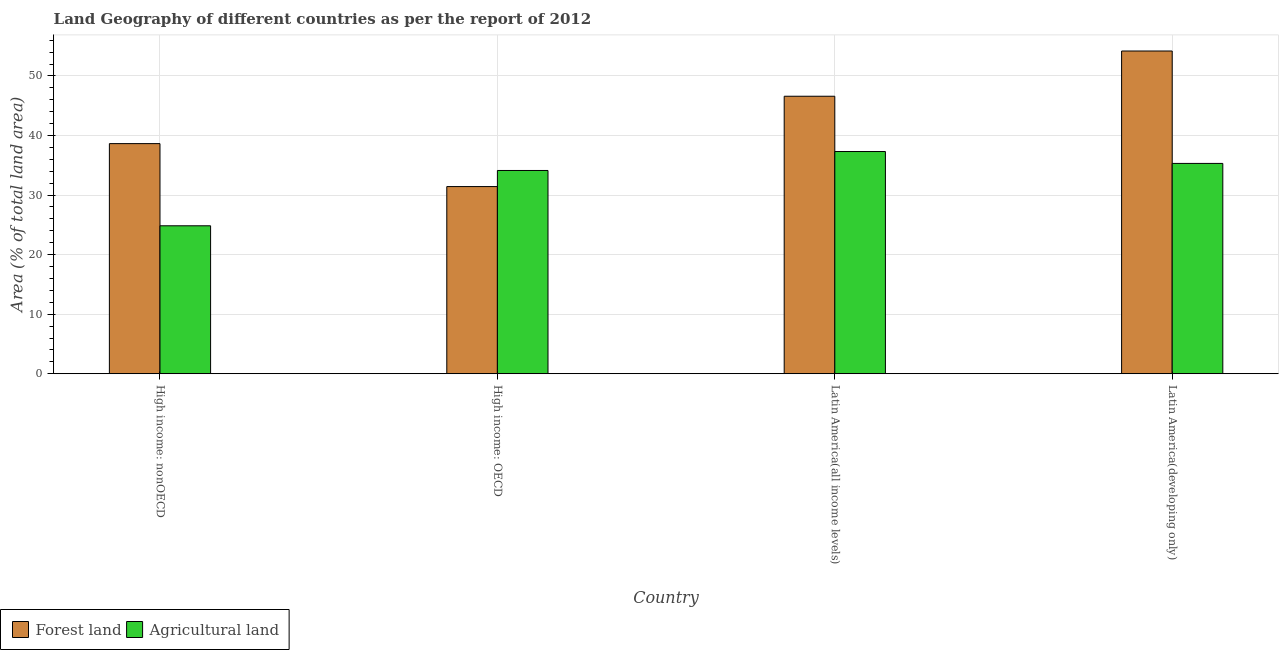Are the number of bars per tick equal to the number of legend labels?
Your answer should be compact. Yes. What is the label of the 3rd group of bars from the left?
Make the answer very short. Latin America(all income levels). In how many cases, is the number of bars for a given country not equal to the number of legend labels?
Provide a succinct answer. 0. What is the percentage of land area under agriculture in Latin America(developing only)?
Offer a terse response. 35.32. Across all countries, what is the maximum percentage of land area under agriculture?
Offer a terse response. 37.31. Across all countries, what is the minimum percentage of land area under forests?
Offer a terse response. 31.43. In which country was the percentage of land area under forests maximum?
Offer a terse response. Latin America(developing only). In which country was the percentage of land area under forests minimum?
Keep it short and to the point. High income: OECD. What is the total percentage of land area under forests in the graph?
Offer a terse response. 170.84. What is the difference between the percentage of land area under agriculture in High income: OECD and that in High income: nonOECD?
Keep it short and to the point. 9.29. What is the difference between the percentage of land area under forests in Latin America(developing only) and the percentage of land area under agriculture in High income: nonOECD?
Keep it short and to the point. 29.35. What is the average percentage of land area under forests per country?
Offer a terse response. 42.71. What is the difference between the percentage of land area under agriculture and percentage of land area under forests in Latin America(developing only)?
Provide a short and direct response. -18.87. What is the ratio of the percentage of land area under forests in High income: nonOECD to that in Latin America(all income levels)?
Offer a terse response. 0.83. Is the percentage of land area under forests in High income: nonOECD less than that in Latin America(developing only)?
Your answer should be compact. Yes. What is the difference between the highest and the second highest percentage of land area under forests?
Provide a succinct answer. 7.59. What is the difference between the highest and the lowest percentage of land area under forests?
Your response must be concise. 22.76. In how many countries, is the percentage of land area under agriculture greater than the average percentage of land area under agriculture taken over all countries?
Ensure brevity in your answer.  3. Is the sum of the percentage of land area under forests in High income: OECD and High income: nonOECD greater than the maximum percentage of land area under agriculture across all countries?
Provide a succinct answer. Yes. What does the 1st bar from the left in High income: nonOECD represents?
Ensure brevity in your answer.  Forest land. What does the 2nd bar from the right in High income: nonOECD represents?
Make the answer very short. Forest land. How many countries are there in the graph?
Provide a short and direct response. 4. What is the difference between two consecutive major ticks on the Y-axis?
Give a very brief answer. 10. Does the graph contain any zero values?
Give a very brief answer. No. Where does the legend appear in the graph?
Make the answer very short. Bottom left. How are the legend labels stacked?
Give a very brief answer. Horizontal. What is the title of the graph?
Provide a short and direct response. Land Geography of different countries as per the report of 2012. What is the label or title of the X-axis?
Keep it short and to the point. Country. What is the label or title of the Y-axis?
Make the answer very short. Area (% of total land area). What is the Area (% of total land area) in Forest land in High income: nonOECD?
Your answer should be very brief. 38.64. What is the Area (% of total land area) in Agricultural land in High income: nonOECD?
Make the answer very short. 24.84. What is the Area (% of total land area) in Forest land in High income: OECD?
Keep it short and to the point. 31.43. What is the Area (% of total land area) in Agricultural land in High income: OECD?
Provide a succinct answer. 34.13. What is the Area (% of total land area) of Forest land in Latin America(all income levels)?
Ensure brevity in your answer.  46.59. What is the Area (% of total land area) of Agricultural land in Latin America(all income levels)?
Provide a short and direct response. 37.31. What is the Area (% of total land area) of Forest land in Latin America(developing only)?
Ensure brevity in your answer.  54.19. What is the Area (% of total land area) of Agricultural land in Latin America(developing only)?
Make the answer very short. 35.32. Across all countries, what is the maximum Area (% of total land area) of Forest land?
Ensure brevity in your answer.  54.19. Across all countries, what is the maximum Area (% of total land area) of Agricultural land?
Provide a short and direct response. 37.31. Across all countries, what is the minimum Area (% of total land area) in Forest land?
Your answer should be compact. 31.43. Across all countries, what is the minimum Area (% of total land area) of Agricultural land?
Provide a short and direct response. 24.84. What is the total Area (% of total land area) in Forest land in the graph?
Ensure brevity in your answer.  170.84. What is the total Area (% of total land area) in Agricultural land in the graph?
Provide a short and direct response. 131.6. What is the difference between the Area (% of total land area) of Forest land in High income: nonOECD and that in High income: OECD?
Your response must be concise. 7.21. What is the difference between the Area (% of total land area) of Agricultural land in High income: nonOECD and that in High income: OECD?
Offer a very short reply. -9.29. What is the difference between the Area (% of total land area) in Forest land in High income: nonOECD and that in Latin America(all income levels)?
Offer a very short reply. -7.95. What is the difference between the Area (% of total land area) in Agricultural land in High income: nonOECD and that in Latin America(all income levels)?
Ensure brevity in your answer.  -12.47. What is the difference between the Area (% of total land area) of Forest land in High income: nonOECD and that in Latin America(developing only)?
Make the answer very short. -15.55. What is the difference between the Area (% of total land area) of Agricultural land in High income: nonOECD and that in Latin America(developing only)?
Give a very brief answer. -10.47. What is the difference between the Area (% of total land area) of Forest land in High income: OECD and that in Latin America(all income levels)?
Your answer should be compact. -15.17. What is the difference between the Area (% of total land area) of Agricultural land in High income: OECD and that in Latin America(all income levels)?
Ensure brevity in your answer.  -3.18. What is the difference between the Area (% of total land area) in Forest land in High income: OECD and that in Latin America(developing only)?
Offer a terse response. -22.76. What is the difference between the Area (% of total land area) of Agricultural land in High income: OECD and that in Latin America(developing only)?
Your response must be concise. -1.19. What is the difference between the Area (% of total land area) in Forest land in Latin America(all income levels) and that in Latin America(developing only)?
Your answer should be compact. -7.59. What is the difference between the Area (% of total land area) of Agricultural land in Latin America(all income levels) and that in Latin America(developing only)?
Your answer should be compact. 2. What is the difference between the Area (% of total land area) of Forest land in High income: nonOECD and the Area (% of total land area) of Agricultural land in High income: OECD?
Offer a terse response. 4.51. What is the difference between the Area (% of total land area) in Forest land in High income: nonOECD and the Area (% of total land area) in Agricultural land in Latin America(all income levels)?
Offer a very short reply. 1.33. What is the difference between the Area (% of total land area) in Forest land in High income: nonOECD and the Area (% of total land area) in Agricultural land in Latin America(developing only)?
Give a very brief answer. 3.32. What is the difference between the Area (% of total land area) of Forest land in High income: OECD and the Area (% of total land area) of Agricultural land in Latin America(all income levels)?
Provide a short and direct response. -5.89. What is the difference between the Area (% of total land area) of Forest land in High income: OECD and the Area (% of total land area) of Agricultural land in Latin America(developing only)?
Your answer should be very brief. -3.89. What is the difference between the Area (% of total land area) in Forest land in Latin America(all income levels) and the Area (% of total land area) in Agricultural land in Latin America(developing only)?
Provide a short and direct response. 11.28. What is the average Area (% of total land area) of Forest land per country?
Keep it short and to the point. 42.71. What is the average Area (% of total land area) of Agricultural land per country?
Make the answer very short. 32.9. What is the difference between the Area (% of total land area) in Forest land and Area (% of total land area) in Agricultural land in High income: nonOECD?
Your response must be concise. 13.8. What is the difference between the Area (% of total land area) of Forest land and Area (% of total land area) of Agricultural land in High income: OECD?
Keep it short and to the point. -2.7. What is the difference between the Area (% of total land area) of Forest land and Area (% of total land area) of Agricultural land in Latin America(all income levels)?
Give a very brief answer. 9.28. What is the difference between the Area (% of total land area) in Forest land and Area (% of total land area) in Agricultural land in Latin America(developing only)?
Offer a very short reply. 18.87. What is the ratio of the Area (% of total land area) of Forest land in High income: nonOECD to that in High income: OECD?
Give a very brief answer. 1.23. What is the ratio of the Area (% of total land area) in Agricultural land in High income: nonOECD to that in High income: OECD?
Give a very brief answer. 0.73. What is the ratio of the Area (% of total land area) in Forest land in High income: nonOECD to that in Latin America(all income levels)?
Offer a very short reply. 0.83. What is the ratio of the Area (% of total land area) of Agricultural land in High income: nonOECD to that in Latin America(all income levels)?
Give a very brief answer. 0.67. What is the ratio of the Area (% of total land area) in Forest land in High income: nonOECD to that in Latin America(developing only)?
Offer a terse response. 0.71. What is the ratio of the Area (% of total land area) in Agricultural land in High income: nonOECD to that in Latin America(developing only)?
Make the answer very short. 0.7. What is the ratio of the Area (% of total land area) of Forest land in High income: OECD to that in Latin America(all income levels)?
Your answer should be compact. 0.67. What is the ratio of the Area (% of total land area) in Agricultural land in High income: OECD to that in Latin America(all income levels)?
Provide a short and direct response. 0.91. What is the ratio of the Area (% of total land area) in Forest land in High income: OECD to that in Latin America(developing only)?
Provide a short and direct response. 0.58. What is the ratio of the Area (% of total land area) in Agricultural land in High income: OECD to that in Latin America(developing only)?
Ensure brevity in your answer.  0.97. What is the ratio of the Area (% of total land area) of Forest land in Latin America(all income levels) to that in Latin America(developing only)?
Offer a very short reply. 0.86. What is the ratio of the Area (% of total land area) in Agricultural land in Latin America(all income levels) to that in Latin America(developing only)?
Your answer should be very brief. 1.06. What is the difference between the highest and the second highest Area (% of total land area) of Forest land?
Give a very brief answer. 7.59. What is the difference between the highest and the second highest Area (% of total land area) in Agricultural land?
Ensure brevity in your answer.  2. What is the difference between the highest and the lowest Area (% of total land area) in Forest land?
Ensure brevity in your answer.  22.76. What is the difference between the highest and the lowest Area (% of total land area) of Agricultural land?
Provide a succinct answer. 12.47. 